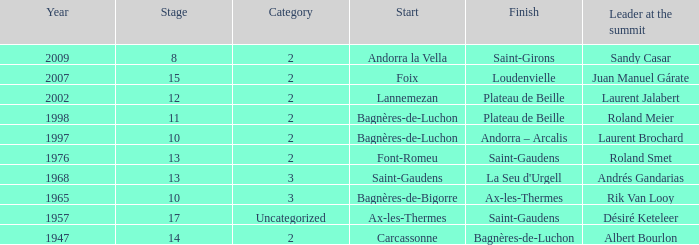Identify the beginning of an occurrence in category 2 of the year 194 Carcassonne. 